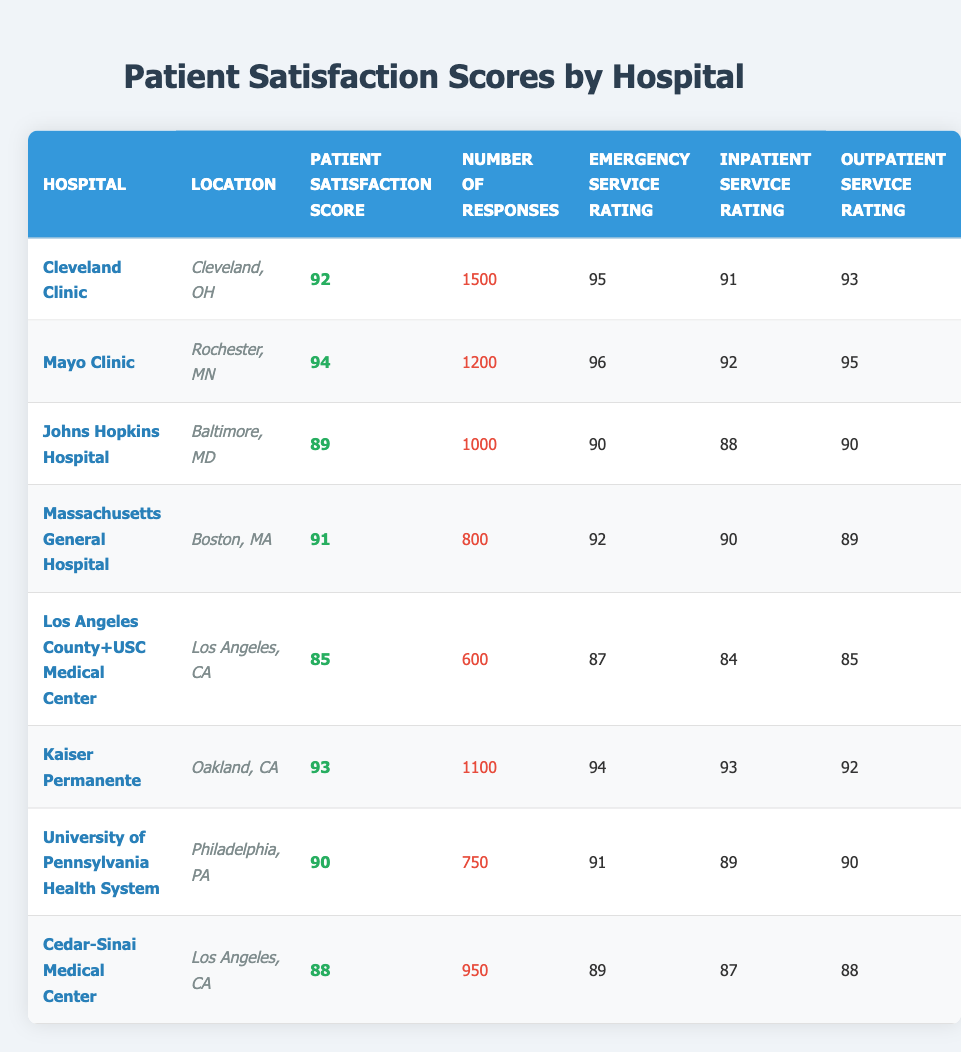What is the patient satisfaction score of Mayo Clinic? The table lists Mayo Clinic with a patient satisfaction score of 94.
Answer: 94 Which hospital has the highest patient satisfaction score? The hospital with the highest patient satisfaction score is Mayo Clinic with a score of 94.
Answer: Mayo Clinic How many responses did Los Angeles County+USC Medical Center receive? The number of responses for Los Angeles County+USC Medical Center is listed as 600.
Answer: 600 Is it true that Johns Hopkins Hospital has a higher patient satisfaction score than Cedar-Sinai Medical Center? Johns Hopkins Hospital has a score of 89, while Cedar-Sinai Medical Center has a score of 88, so this statement is true.
Answer: Yes Which hospital has the lowest emergency service rating, and what is its value? The hospital with the lowest emergency service rating is Los Angeles County+USC Medical Center, rating at 87.
Answer: Los Angeles County+USC Medical Center, 87 Calculate the average patient satisfaction score of the hospitals listed. The scores are 92, 94, 89, 91, 85, 93, 90, and 88. Summing these gives 92 + 94 + 89 + 91 + 85 + 93 + 90 + 88 = 720. Dividing by 8 gives an average of 720 / 8 = 90.
Answer: 90 What is the emergency service rating for Kaiser Permanente? The emergency service rating for Kaiser Permanente is listed as 94.
Answer: 94 What is the difference in patient satisfaction scores between Cleveland Clinic and Johns Hopkins Hospital? Cleveland Clinic has a score of 92 while Johns Hopkins Hospital has 89. The difference is 92 - 89 = 3.
Answer: 3 How many hospitals have a patient satisfaction score above 90? The hospitals above 90 are Mayo Clinic, Cleveland Clinic, and Kaiser Permanente, totaling 3 hospitals.
Answer: 3 Which location has the hospital with the highest outpatient service rating, and what is that rating? The highest outpatient service rating is 95 at Mayo Clinic located in Rochester, MN.
Answer: Rochester, MN, 95 What is the combined number of responses for the hospitals in Los Angeles? The two hospitals in Los Angeles are Los Angeles County+USC Medical Center (600 responses) and Cedar-Sinai Medical Center (950 responses). The sum is 600 + 950 = 1550.
Answer: 1550 Is it true that the patient satisfaction scores for all hospitals listed are above 85? All patient satisfaction scores listed are above 85, confirming the statement is true.
Answer: Yes 